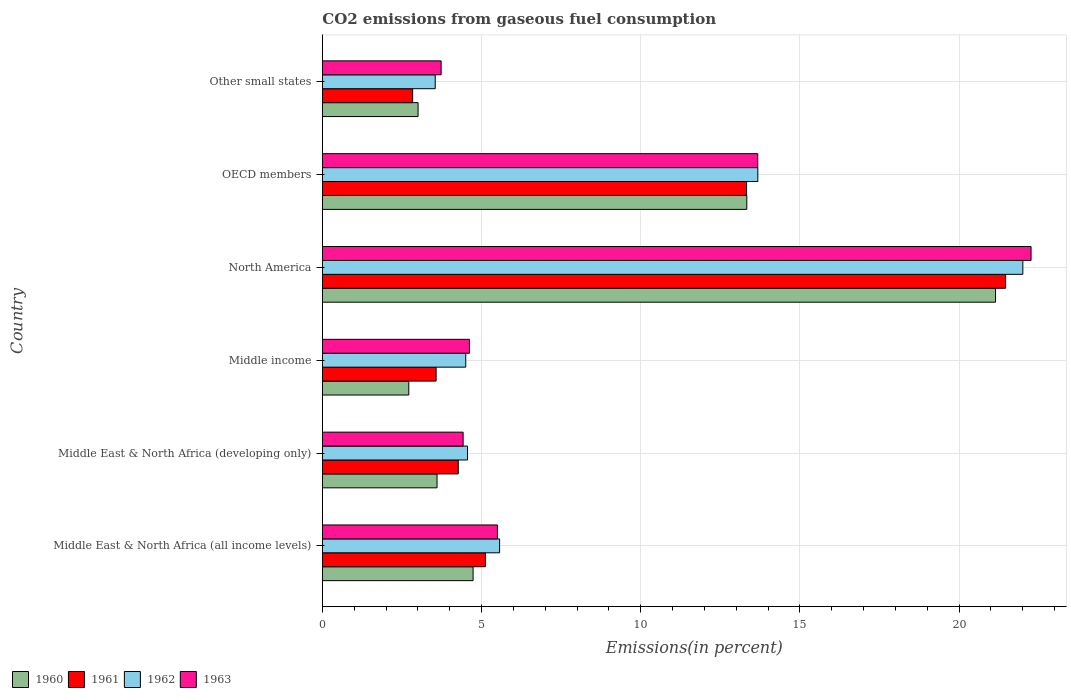How many groups of bars are there?
Make the answer very short. 6. How many bars are there on the 6th tick from the top?
Provide a succinct answer. 4. How many bars are there on the 3rd tick from the bottom?
Provide a short and direct response. 4. What is the label of the 1st group of bars from the top?
Offer a very short reply. Other small states. In how many cases, is the number of bars for a given country not equal to the number of legend labels?
Make the answer very short. 0. What is the total CO2 emitted in 1961 in OECD members?
Make the answer very short. 13.33. Across all countries, what is the maximum total CO2 emitted in 1961?
Your answer should be very brief. 21.46. Across all countries, what is the minimum total CO2 emitted in 1962?
Offer a very short reply. 3.55. In which country was the total CO2 emitted in 1961 minimum?
Offer a very short reply. Other small states. What is the total total CO2 emitted in 1962 in the graph?
Provide a succinct answer. 53.86. What is the difference between the total CO2 emitted in 1960 in Middle income and that in Other small states?
Offer a terse response. -0.29. What is the difference between the total CO2 emitted in 1961 in Middle income and the total CO2 emitted in 1963 in North America?
Your response must be concise. -18.69. What is the average total CO2 emitted in 1962 per country?
Give a very brief answer. 8.98. What is the difference between the total CO2 emitted in 1961 and total CO2 emitted in 1962 in OECD members?
Your answer should be very brief. -0.35. What is the ratio of the total CO2 emitted in 1961 in Middle East & North Africa (developing only) to that in North America?
Give a very brief answer. 0.2. Is the difference between the total CO2 emitted in 1961 in Middle income and OECD members greater than the difference between the total CO2 emitted in 1962 in Middle income and OECD members?
Your answer should be very brief. No. What is the difference between the highest and the second highest total CO2 emitted in 1961?
Offer a very short reply. 8.14. What is the difference between the highest and the lowest total CO2 emitted in 1960?
Make the answer very short. 18.43. Is the sum of the total CO2 emitted in 1963 in North America and Other small states greater than the maximum total CO2 emitted in 1960 across all countries?
Your answer should be very brief. Yes. What does the 3rd bar from the bottom in Middle East & North Africa (all income levels) represents?
Give a very brief answer. 1962. Is it the case that in every country, the sum of the total CO2 emitted in 1963 and total CO2 emitted in 1962 is greater than the total CO2 emitted in 1960?
Provide a succinct answer. Yes. Are all the bars in the graph horizontal?
Provide a succinct answer. Yes. What is the difference between two consecutive major ticks on the X-axis?
Make the answer very short. 5. Does the graph contain grids?
Offer a very short reply. Yes. Where does the legend appear in the graph?
Provide a succinct answer. Bottom left. How are the legend labels stacked?
Make the answer very short. Horizontal. What is the title of the graph?
Offer a terse response. CO2 emissions from gaseous fuel consumption. Does "2011" appear as one of the legend labels in the graph?
Your response must be concise. No. What is the label or title of the X-axis?
Your answer should be very brief. Emissions(in percent). What is the label or title of the Y-axis?
Provide a succinct answer. Country. What is the Emissions(in percent) of 1960 in Middle East & North Africa (all income levels)?
Your answer should be compact. 4.74. What is the Emissions(in percent) in 1961 in Middle East & North Africa (all income levels)?
Your response must be concise. 5.12. What is the Emissions(in percent) of 1962 in Middle East & North Africa (all income levels)?
Make the answer very short. 5.57. What is the Emissions(in percent) in 1963 in Middle East & North Africa (all income levels)?
Offer a very short reply. 5.5. What is the Emissions(in percent) in 1960 in Middle East & North Africa (developing only)?
Ensure brevity in your answer.  3.6. What is the Emissions(in percent) in 1961 in Middle East & North Africa (developing only)?
Provide a short and direct response. 4.27. What is the Emissions(in percent) of 1962 in Middle East & North Africa (developing only)?
Your answer should be compact. 4.56. What is the Emissions(in percent) of 1963 in Middle East & North Africa (developing only)?
Keep it short and to the point. 4.42. What is the Emissions(in percent) of 1960 in Middle income?
Your response must be concise. 2.72. What is the Emissions(in percent) of 1961 in Middle income?
Give a very brief answer. 3.57. What is the Emissions(in percent) in 1962 in Middle income?
Your answer should be very brief. 4.5. What is the Emissions(in percent) of 1963 in Middle income?
Make the answer very short. 4.62. What is the Emissions(in percent) of 1960 in North America?
Ensure brevity in your answer.  21.15. What is the Emissions(in percent) of 1961 in North America?
Ensure brevity in your answer.  21.46. What is the Emissions(in percent) of 1962 in North America?
Your response must be concise. 22. What is the Emissions(in percent) in 1963 in North America?
Provide a short and direct response. 22.26. What is the Emissions(in percent) in 1960 in OECD members?
Your response must be concise. 13.33. What is the Emissions(in percent) of 1961 in OECD members?
Provide a short and direct response. 13.33. What is the Emissions(in percent) in 1962 in OECD members?
Your response must be concise. 13.68. What is the Emissions(in percent) of 1963 in OECD members?
Your response must be concise. 13.68. What is the Emissions(in percent) of 1960 in Other small states?
Provide a short and direct response. 3.01. What is the Emissions(in percent) in 1961 in Other small states?
Your answer should be compact. 2.84. What is the Emissions(in percent) in 1962 in Other small states?
Offer a terse response. 3.55. What is the Emissions(in percent) in 1963 in Other small states?
Your response must be concise. 3.73. Across all countries, what is the maximum Emissions(in percent) in 1960?
Provide a succinct answer. 21.15. Across all countries, what is the maximum Emissions(in percent) in 1961?
Offer a very short reply. 21.46. Across all countries, what is the maximum Emissions(in percent) in 1962?
Your response must be concise. 22. Across all countries, what is the maximum Emissions(in percent) in 1963?
Offer a very short reply. 22.26. Across all countries, what is the minimum Emissions(in percent) in 1960?
Make the answer very short. 2.72. Across all countries, what is the minimum Emissions(in percent) in 1961?
Your answer should be compact. 2.84. Across all countries, what is the minimum Emissions(in percent) of 1962?
Your response must be concise. 3.55. Across all countries, what is the minimum Emissions(in percent) of 1963?
Give a very brief answer. 3.73. What is the total Emissions(in percent) of 1960 in the graph?
Your answer should be very brief. 48.54. What is the total Emissions(in percent) of 1961 in the graph?
Give a very brief answer. 50.59. What is the total Emissions(in percent) in 1962 in the graph?
Provide a succinct answer. 53.86. What is the total Emissions(in percent) of 1963 in the graph?
Your answer should be very brief. 54.21. What is the difference between the Emissions(in percent) of 1960 in Middle East & North Africa (all income levels) and that in Middle East & North Africa (developing only)?
Your answer should be very brief. 1.13. What is the difference between the Emissions(in percent) in 1961 in Middle East & North Africa (all income levels) and that in Middle East & North Africa (developing only)?
Make the answer very short. 0.85. What is the difference between the Emissions(in percent) in 1962 in Middle East & North Africa (all income levels) and that in Middle East & North Africa (developing only)?
Offer a very short reply. 1.01. What is the difference between the Emissions(in percent) in 1963 in Middle East & North Africa (all income levels) and that in Middle East & North Africa (developing only)?
Offer a terse response. 1.08. What is the difference between the Emissions(in percent) in 1960 in Middle East & North Africa (all income levels) and that in Middle income?
Ensure brevity in your answer.  2.02. What is the difference between the Emissions(in percent) in 1961 in Middle East & North Africa (all income levels) and that in Middle income?
Offer a very short reply. 1.55. What is the difference between the Emissions(in percent) in 1962 in Middle East & North Africa (all income levels) and that in Middle income?
Make the answer very short. 1.06. What is the difference between the Emissions(in percent) in 1963 in Middle East & North Africa (all income levels) and that in Middle income?
Your answer should be compact. 0.88. What is the difference between the Emissions(in percent) of 1960 in Middle East & North Africa (all income levels) and that in North America?
Offer a very short reply. -16.41. What is the difference between the Emissions(in percent) of 1961 in Middle East & North Africa (all income levels) and that in North America?
Your response must be concise. -16.34. What is the difference between the Emissions(in percent) in 1962 in Middle East & North Africa (all income levels) and that in North America?
Make the answer very short. -16.44. What is the difference between the Emissions(in percent) in 1963 in Middle East & North Africa (all income levels) and that in North America?
Make the answer very short. -16.76. What is the difference between the Emissions(in percent) of 1960 in Middle East & North Africa (all income levels) and that in OECD members?
Give a very brief answer. -8.6. What is the difference between the Emissions(in percent) in 1961 in Middle East & North Africa (all income levels) and that in OECD members?
Give a very brief answer. -8.2. What is the difference between the Emissions(in percent) in 1962 in Middle East & North Africa (all income levels) and that in OECD members?
Provide a short and direct response. -8.11. What is the difference between the Emissions(in percent) of 1963 in Middle East & North Africa (all income levels) and that in OECD members?
Provide a short and direct response. -8.18. What is the difference between the Emissions(in percent) in 1960 in Middle East & North Africa (all income levels) and that in Other small states?
Keep it short and to the point. 1.73. What is the difference between the Emissions(in percent) in 1961 in Middle East & North Africa (all income levels) and that in Other small states?
Your answer should be compact. 2.29. What is the difference between the Emissions(in percent) in 1962 in Middle East & North Africa (all income levels) and that in Other small states?
Offer a very short reply. 2.02. What is the difference between the Emissions(in percent) of 1963 in Middle East & North Africa (all income levels) and that in Other small states?
Provide a succinct answer. 1.77. What is the difference between the Emissions(in percent) in 1960 in Middle East & North Africa (developing only) and that in Middle income?
Offer a very short reply. 0.89. What is the difference between the Emissions(in percent) in 1961 in Middle East & North Africa (developing only) and that in Middle income?
Your answer should be very brief. 0.7. What is the difference between the Emissions(in percent) in 1962 in Middle East & North Africa (developing only) and that in Middle income?
Provide a succinct answer. 0.06. What is the difference between the Emissions(in percent) of 1963 in Middle East & North Africa (developing only) and that in Middle income?
Provide a succinct answer. -0.2. What is the difference between the Emissions(in percent) in 1960 in Middle East & North Africa (developing only) and that in North America?
Your answer should be compact. -17.54. What is the difference between the Emissions(in percent) of 1961 in Middle East & North Africa (developing only) and that in North America?
Give a very brief answer. -17.19. What is the difference between the Emissions(in percent) in 1962 in Middle East & North Africa (developing only) and that in North America?
Your answer should be compact. -17.44. What is the difference between the Emissions(in percent) in 1963 in Middle East & North Africa (developing only) and that in North America?
Make the answer very short. -17.84. What is the difference between the Emissions(in percent) in 1960 in Middle East & North Africa (developing only) and that in OECD members?
Keep it short and to the point. -9.73. What is the difference between the Emissions(in percent) in 1961 in Middle East & North Africa (developing only) and that in OECD members?
Ensure brevity in your answer.  -9.06. What is the difference between the Emissions(in percent) of 1962 in Middle East & North Africa (developing only) and that in OECD members?
Provide a succinct answer. -9.12. What is the difference between the Emissions(in percent) in 1963 in Middle East & North Africa (developing only) and that in OECD members?
Your answer should be compact. -9.25. What is the difference between the Emissions(in percent) in 1960 in Middle East & North Africa (developing only) and that in Other small states?
Give a very brief answer. 0.6. What is the difference between the Emissions(in percent) of 1961 in Middle East & North Africa (developing only) and that in Other small states?
Your answer should be compact. 1.43. What is the difference between the Emissions(in percent) of 1962 in Middle East & North Africa (developing only) and that in Other small states?
Provide a succinct answer. 1.01. What is the difference between the Emissions(in percent) in 1963 in Middle East & North Africa (developing only) and that in Other small states?
Make the answer very short. 0.69. What is the difference between the Emissions(in percent) in 1960 in Middle income and that in North America?
Give a very brief answer. -18.43. What is the difference between the Emissions(in percent) of 1961 in Middle income and that in North America?
Offer a very short reply. -17.89. What is the difference between the Emissions(in percent) of 1962 in Middle income and that in North America?
Give a very brief answer. -17.5. What is the difference between the Emissions(in percent) in 1963 in Middle income and that in North America?
Keep it short and to the point. -17.64. What is the difference between the Emissions(in percent) of 1960 in Middle income and that in OECD members?
Provide a succinct answer. -10.62. What is the difference between the Emissions(in percent) of 1961 in Middle income and that in OECD members?
Offer a terse response. -9.75. What is the difference between the Emissions(in percent) of 1962 in Middle income and that in OECD members?
Your answer should be very brief. -9.17. What is the difference between the Emissions(in percent) of 1963 in Middle income and that in OECD members?
Offer a very short reply. -9.06. What is the difference between the Emissions(in percent) of 1960 in Middle income and that in Other small states?
Make the answer very short. -0.29. What is the difference between the Emissions(in percent) of 1961 in Middle income and that in Other small states?
Make the answer very short. 0.74. What is the difference between the Emissions(in percent) in 1962 in Middle income and that in Other small states?
Keep it short and to the point. 0.96. What is the difference between the Emissions(in percent) in 1963 in Middle income and that in Other small states?
Your answer should be very brief. 0.89. What is the difference between the Emissions(in percent) of 1960 in North America and that in OECD members?
Your answer should be very brief. 7.81. What is the difference between the Emissions(in percent) in 1961 in North America and that in OECD members?
Provide a succinct answer. 8.14. What is the difference between the Emissions(in percent) in 1962 in North America and that in OECD members?
Make the answer very short. 8.32. What is the difference between the Emissions(in percent) in 1963 in North America and that in OECD members?
Keep it short and to the point. 8.58. What is the difference between the Emissions(in percent) of 1960 in North America and that in Other small states?
Provide a succinct answer. 18.14. What is the difference between the Emissions(in percent) in 1961 in North America and that in Other small states?
Give a very brief answer. 18.62. What is the difference between the Emissions(in percent) in 1962 in North America and that in Other small states?
Make the answer very short. 18.46. What is the difference between the Emissions(in percent) of 1963 in North America and that in Other small states?
Keep it short and to the point. 18.53. What is the difference between the Emissions(in percent) in 1960 in OECD members and that in Other small states?
Offer a terse response. 10.33. What is the difference between the Emissions(in percent) in 1961 in OECD members and that in Other small states?
Ensure brevity in your answer.  10.49. What is the difference between the Emissions(in percent) of 1962 in OECD members and that in Other small states?
Ensure brevity in your answer.  10.13. What is the difference between the Emissions(in percent) of 1963 in OECD members and that in Other small states?
Provide a succinct answer. 9.95. What is the difference between the Emissions(in percent) in 1960 in Middle East & North Africa (all income levels) and the Emissions(in percent) in 1961 in Middle East & North Africa (developing only)?
Your response must be concise. 0.47. What is the difference between the Emissions(in percent) in 1960 in Middle East & North Africa (all income levels) and the Emissions(in percent) in 1962 in Middle East & North Africa (developing only)?
Provide a succinct answer. 0.18. What is the difference between the Emissions(in percent) of 1960 in Middle East & North Africa (all income levels) and the Emissions(in percent) of 1963 in Middle East & North Africa (developing only)?
Your answer should be compact. 0.31. What is the difference between the Emissions(in percent) of 1961 in Middle East & North Africa (all income levels) and the Emissions(in percent) of 1962 in Middle East & North Africa (developing only)?
Provide a succinct answer. 0.56. What is the difference between the Emissions(in percent) of 1961 in Middle East & North Africa (all income levels) and the Emissions(in percent) of 1963 in Middle East & North Africa (developing only)?
Your answer should be very brief. 0.7. What is the difference between the Emissions(in percent) of 1962 in Middle East & North Africa (all income levels) and the Emissions(in percent) of 1963 in Middle East & North Africa (developing only)?
Your answer should be compact. 1.15. What is the difference between the Emissions(in percent) in 1960 in Middle East & North Africa (all income levels) and the Emissions(in percent) in 1961 in Middle income?
Make the answer very short. 1.16. What is the difference between the Emissions(in percent) in 1960 in Middle East & North Africa (all income levels) and the Emissions(in percent) in 1962 in Middle income?
Offer a terse response. 0.23. What is the difference between the Emissions(in percent) in 1960 in Middle East & North Africa (all income levels) and the Emissions(in percent) in 1963 in Middle income?
Offer a terse response. 0.12. What is the difference between the Emissions(in percent) in 1961 in Middle East & North Africa (all income levels) and the Emissions(in percent) in 1962 in Middle income?
Offer a very short reply. 0.62. What is the difference between the Emissions(in percent) of 1961 in Middle East & North Africa (all income levels) and the Emissions(in percent) of 1963 in Middle income?
Ensure brevity in your answer.  0.5. What is the difference between the Emissions(in percent) of 1962 in Middle East & North Africa (all income levels) and the Emissions(in percent) of 1963 in Middle income?
Your answer should be very brief. 0.95. What is the difference between the Emissions(in percent) of 1960 in Middle East & North Africa (all income levels) and the Emissions(in percent) of 1961 in North America?
Provide a succinct answer. -16.73. What is the difference between the Emissions(in percent) of 1960 in Middle East & North Africa (all income levels) and the Emissions(in percent) of 1962 in North America?
Your answer should be compact. -17.27. What is the difference between the Emissions(in percent) of 1960 in Middle East & North Africa (all income levels) and the Emissions(in percent) of 1963 in North America?
Ensure brevity in your answer.  -17.53. What is the difference between the Emissions(in percent) of 1961 in Middle East & North Africa (all income levels) and the Emissions(in percent) of 1962 in North America?
Offer a terse response. -16.88. What is the difference between the Emissions(in percent) in 1961 in Middle East & North Africa (all income levels) and the Emissions(in percent) in 1963 in North America?
Make the answer very short. -17.14. What is the difference between the Emissions(in percent) in 1962 in Middle East & North Africa (all income levels) and the Emissions(in percent) in 1963 in North America?
Offer a very short reply. -16.69. What is the difference between the Emissions(in percent) of 1960 in Middle East & North Africa (all income levels) and the Emissions(in percent) of 1961 in OECD members?
Provide a succinct answer. -8.59. What is the difference between the Emissions(in percent) of 1960 in Middle East & North Africa (all income levels) and the Emissions(in percent) of 1962 in OECD members?
Give a very brief answer. -8.94. What is the difference between the Emissions(in percent) of 1960 in Middle East & North Africa (all income levels) and the Emissions(in percent) of 1963 in OECD members?
Offer a terse response. -8.94. What is the difference between the Emissions(in percent) in 1961 in Middle East & North Africa (all income levels) and the Emissions(in percent) in 1962 in OECD members?
Ensure brevity in your answer.  -8.56. What is the difference between the Emissions(in percent) of 1961 in Middle East & North Africa (all income levels) and the Emissions(in percent) of 1963 in OECD members?
Keep it short and to the point. -8.55. What is the difference between the Emissions(in percent) of 1962 in Middle East & North Africa (all income levels) and the Emissions(in percent) of 1963 in OECD members?
Keep it short and to the point. -8.11. What is the difference between the Emissions(in percent) in 1960 in Middle East & North Africa (all income levels) and the Emissions(in percent) in 1961 in Other small states?
Provide a succinct answer. 1.9. What is the difference between the Emissions(in percent) of 1960 in Middle East & North Africa (all income levels) and the Emissions(in percent) of 1962 in Other small states?
Give a very brief answer. 1.19. What is the difference between the Emissions(in percent) of 1961 in Middle East & North Africa (all income levels) and the Emissions(in percent) of 1962 in Other small states?
Ensure brevity in your answer.  1.58. What is the difference between the Emissions(in percent) in 1961 in Middle East & North Africa (all income levels) and the Emissions(in percent) in 1963 in Other small states?
Give a very brief answer. 1.39. What is the difference between the Emissions(in percent) of 1962 in Middle East & North Africa (all income levels) and the Emissions(in percent) of 1963 in Other small states?
Make the answer very short. 1.84. What is the difference between the Emissions(in percent) in 1960 in Middle East & North Africa (developing only) and the Emissions(in percent) in 1961 in Middle income?
Make the answer very short. 0.03. What is the difference between the Emissions(in percent) of 1960 in Middle East & North Africa (developing only) and the Emissions(in percent) of 1962 in Middle income?
Ensure brevity in your answer.  -0.9. What is the difference between the Emissions(in percent) in 1960 in Middle East & North Africa (developing only) and the Emissions(in percent) in 1963 in Middle income?
Keep it short and to the point. -1.02. What is the difference between the Emissions(in percent) in 1961 in Middle East & North Africa (developing only) and the Emissions(in percent) in 1962 in Middle income?
Offer a terse response. -0.24. What is the difference between the Emissions(in percent) of 1961 in Middle East & North Africa (developing only) and the Emissions(in percent) of 1963 in Middle income?
Your response must be concise. -0.35. What is the difference between the Emissions(in percent) of 1962 in Middle East & North Africa (developing only) and the Emissions(in percent) of 1963 in Middle income?
Offer a terse response. -0.06. What is the difference between the Emissions(in percent) of 1960 in Middle East & North Africa (developing only) and the Emissions(in percent) of 1961 in North America?
Provide a short and direct response. -17.86. What is the difference between the Emissions(in percent) in 1960 in Middle East & North Africa (developing only) and the Emissions(in percent) in 1962 in North America?
Give a very brief answer. -18.4. What is the difference between the Emissions(in percent) in 1960 in Middle East & North Africa (developing only) and the Emissions(in percent) in 1963 in North America?
Keep it short and to the point. -18.66. What is the difference between the Emissions(in percent) in 1961 in Middle East & North Africa (developing only) and the Emissions(in percent) in 1962 in North America?
Make the answer very short. -17.73. What is the difference between the Emissions(in percent) of 1961 in Middle East & North Africa (developing only) and the Emissions(in percent) of 1963 in North America?
Keep it short and to the point. -17.99. What is the difference between the Emissions(in percent) in 1962 in Middle East & North Africa (developing only) and the Emissions(in percent) in 1963 in North America?
Provide a succinct answer. -17.7. What is the difference between the Emissions(in percent) in 1960 in Middle East & North Africa (developing only) and the Emissions(in percent) in 1961 in OECD members?
Offer a terse response. -9.72. What is the difference between the Emissions(in percent) of 1960 in Middle East & North Africa (developing only) and the Emissions(in percent) of 1962 in OECD members?
Keep it short and to the point. -10.08. What is the difference between the Emissions(in percent) in 1960 in Middle East & North Africa (developing only) and the Emissions(in percent) in 1963 in OECD members?
Provide a short and direct response. -10.07. What is the difference between the Emissions(in percent) of 1961 in Middle East & North Africa (developing only) and the Emissions(in percent) of 1962 in OECD members?
Offer a very short reply. -9.41. What is the difference between the Emissions(in percent) in 1961 in Middle East & North Africa (developing only) and the Emissions(in percent) in 1963 in OECD members?
Offer a terse response. -9.41. What is the difference between the Emissions(in percent) in 1962 in Middle East & North Africa (developing only) and the Emissions(in percent) in 1963 in OECD members?
Keep it short and to the point. -9.12. What is the difference between the Emissions(in percent) in 1960 in Middle East & North Africa (developing only) and the Emissions(in percent) in 1961 in Other small states?
Your response must be concise. 0.77. What is the difference between the Emissions(in percent) in 1960 in Middle East & North Africa (developing only) and the Emissions(in percent) in 1962 in Other small states?
Your answer should be very brief. 0.06. What is the difference between the Emissions(in percent) in 1960 in Middle East & North Africa (developing only) and the Emissions(in percent) in 1963 in Other small states?
Offer a very short reply. -0.13. What is the difference between the Emissions(in percent) of 1961 in Middle East & North Africa (developing only) and the Emissions(in percent) of 1962 in Other small states?
Make the answer very short. 0.72. What is the difference between the Emissions(in percent) of 1961 in Middle East & North Africa (developing only) and the Emissions(in percent) of 1963 in Other small states?
Keep it short and to the point. 0.54. What is the difference between the Emissions(in percent) of 1962 in Middle East & North Africa (developing only) and the Emissions(in percent) of 1963 in Other small states?
Keep it short and to the point. 0.83. What is the difference between the Emissions(in percent) in 1960 in Middle income and the Emissions(in percent) in 1961 in North America?
Make the answer very short. -18.75. What is the difference between the Emissions(in percent) of 1960 in Middle income and the Emissions(in percent) of 1962 in North America?
Offer a terse response. -19.29. What is the difference between the Emissions(in percent) in 1960 in Middle income and the Emissions(in percent) in 1963 in North America?
Keep it short and to the point. -19.55. What is the difference between the Emissions(in percent) in 1961 in Middle income and the Emissions(in percent) in 1962 in North America?
Your answer should be very brief. -18.43. What is the difference between the Emissions(in percent) of 1961 in Middle income and the Emissions(in percent) of 1963 in North America?
Your answer should be compact. -18.69. What is the difference between the Emissions(in percent) of 1962 in Middle income and the Emissions(in percent) of 1963 in North America?
Your answer should be very brief. -17.76. What is the difference between the Emissions(in percent) of 1960 in Middle income and the Emissions(in percent) of 1961 in OECD members?
Provide a short and direct response. -10.61. What is the difference between the Emissions(in percent) in 1960 in Middle income and the Emissions(in percent) in 1962 in OECD members?
Make the answer very short. -10.96. What is the difference between the Emissions(in percent) in 1960 in Middle income and the Emissions(in percent) in 1963 in OECD members?
Your answer should be very brief. -10.96. What is the difference between the Emissions(in percent) of 1961 in Middle income and the Emissions(in percent) of 1962 in OECD members?
Ensure brevity in your answer.  -10.11. What is the difference between the Emissions(in percent) of 1961 in Middle income and the Emissions(in percent) of 1963 in OECD members?
Give a very brief answer. -10.1. What is the difference between the Emissions(in percent) in 1962 in Middle income and the Emissions(in percent) in 1963 in OECD members?
Your response must be concise. -9.17. What is the difference between the Emissions(in percent) in 1960 in Middle income and the Emissions(in percent) in 1961 in Other small states?
Your answer should be compact. -0.12. What is the difference between the Emissions(in percent) of 1960 in Middle income and the Emissions(in percent) of 1962 in Other small states?
Provide a succinct answer. -0.83. What is the difference between the Emissions(in percent) in 1960 in Middle income and the Emissions(in percent) in 1963 in Other small states?
Keep it short and to the point. -1.02. What is the difference between the Emissions(in percent) of 1961 in Middle income and the Emissions(in percent) of 1962 in Other small states?
Your answer should be compact. 0.03. What is the difference between the Emissions(in percent) in 1961 in Middle income and the Emissions(in percent) in 1963 in Other small states?
Offer a very short reply. -0.16. What is the difference between the Emissions(in percent) of 1962 in Middle income and the Emissions(in percent) of 1963 in Other small states?
Provide a short and direct response. 0.77. What is the difference between the Emissions(in percent) of 1960 in North America and the Emissions(in percent) of 1961 in OECD members?
Provide a succinct answer. 7.82. What is the difference between the Emissions(in percent) of 1960 in North America and the Emissions(in percent) of 1962 in OECD members?
Offer a very short reply. 7.47. What is the difference between the Emissions(in percent) of 1960 in North America and the Emissions(in percent) of 1963 in OECD members?
Offer a terse response. 7.47. What is the difference between the Emissions(in percent) of 1961 in North America and the Emissions(in percent) of 1962 in OECD members?
Make the answer very short. 7.78. What is the difference between the Emissions(in percent) of 1961 in North America and the Emissions(in percent) of 1963 in OECD members?
Your answer should be very brief. 7.78. What is the difference between the Emissions(in percent) in 1962 in North America and the Emissions(in percent) in 1963 in OECD members?
Give a very brief answer. 8.33. What is the difference between the Emissions(in percent) of 1960 in North America and the Emissions(in percent) of 1961 in Other small states?
Make the answer very short. 18.31. What is the difference between the Emissions(in percent) of 1960 in North America and the Emissions(in percent) of 1962 in Other small states?
Keep it short and to the point. 17.6. What is the difference between the Emissions(in percent) in 1960 in North America and the Emissions(in percent) in 1963 in Other small states?
Make the answer very short. 17.41. What is the difference between the Emissions(in percent) of 1961 in North America and the Emissions(in percent) of 1962 in Other small states?
Provide a short and direct response. 17.92. What is the difference between the Emissions(in percent) of 1961 in North America and the Emissions(in percent) of 1963 in Other small states?
Make the answer very short. 17.73. What is the difference between the Emissions(in percent) in 1962 in North America and the Emissions(in percent) in 1963 in Other small states?
Provide a short and direct response. 18.27. What is the difference between the Emissions(in percent) of 1960 in OECD members and the Emissions(in percent) of 1961 in Other small states?
Keep it short and to the point. 10.5. What is the difference between the Emissions(in percent) of 1960 in OECD members and the Emissions(in percent) of 1962 in Other small states?
Provide a short and direct response. 9.79. What is the difference between the Emissions(in percent) in 1960 in OECD members and the Emissions(in percent) in 1963 in Other small states?
Ensure brevity in your answer.  9.6. What is the difference between the Emissions(in percent) in 1961 in OECD members and the Emissions(in percent) in 1962 in Other small states?
Your answer should be very brief. 9.78. What is the difference between the Emissions(in percent) in 1961 in OECD members and the Emissions(in percent) in 1963 in Other small states?
Ensure brevity in your answer.  9.59. What is the difference between the Emissions(in percent) in 1962 in OECD members and the Emissions(in percent) in 1963 in Other small states?
Give a very brief answer. 9.95. What is the average Emissions(in percent) of 1960 per country?
Keep it short and to the point. 8.09. What is the average Emissions(in percent) of 1961 per country?
Provide a succinct answer. 8.43. What is the average Emissions(in percent) of 1962 per country?
Give a very brief answer. 8.98. What is the average Emissions(in percent) of 1963 per country?
Provide a short and direct response. 9.04. What is the difference between the Emissions(in percent) of 1960 and Emissions(in percent) of 1961 in Middle East & North Africa (all income levels)?
Make the answer very short. -0.39. What is the difference between the Emissions(in percent) of 1960 and Emissions(in percent) of 1962 in Middle East & North Africa (all income levels)?
Offer a terse response. -0.83. What is the difference between the Emissions(in percent) of 1960 and Emissions(in percent) of 1963 in Middle East & North Africa (all income levels)?
Your response must be concise. -0.76. What is the difference between the Emissions(in percent) of 1961 and Emissions(in percent) of 1962 in Middle East & North Africa (all income levels)?
Make the answer very short. -0.45. What is the difference between the Emissions(in percent) of 1961 and Emissions(in percent) of 1963 in Middle East & North Africa (all income levels)?
Ensure brevity in your answer.  -0.38. What is the difference between the Emissions(in percent) in 1962 and Emissions(in percent) in 1963 in Middle East & North Africa (all income levels)?
Provide a short and direct response. 0.07. What is the difference between the Emissions(in percent) of 1960 and Emissions(in percent) of 1961 in Middle East & North Africa (developing only)?
Keep it short and to the point. -0.67. What is the difference between the Emissions(in percent) of 1960 and Emissions(in percent) of 1962 in Middle East & North Africa (developing only)?
Make the answer very short. -0.96. What is the difference between the Emissions(in percent) of 1960 and Emissions(in percent) of 1963 in Middle East & North Africa (developing only)?
Provide a succinct answer. -0.82. What is the difference between the Emissions(in percent) in 1961 and Emissions(in percent) in 1962 in Middle East & North Africa (developing only)?
Provide a succinct answer. -0.29. What is the difference between the Emissions(in percent) of 1961 and Emissions(in percent) of 1963 in Middle East & North Africa (developing only)?
Your answer should be very brief. -0.15. What is the difference between the Emissions(in percent) of 1962 and Emissions(in percent) of 1963 in Middle East & North Africa (developing only)?
Your response must be concise. 0.14. What is the difference between the Emissions(in percent) of 1960 and Emissions(in percent) of 1961 in Middle income?
Provide a succinct answer. -0.86. What is the difference between the Emissions(in percent) of 1960 and Emissions(in percent) of 1962 in Middle income?
Provide a short and direct response. -1.79. What is the difference between the Emissions(in percent) of 1960 and Emissions(in percent) of 1963 in Middle income?
Make the answer very short. -1.91. What is the difference between the Emissions(in percent) of 1961 and Emissions(in percent) of 1962 in Middle income?
Your response must be concise. -0.93. What is the difference between the Emissions(in percent) in 1961 and Emissions(in percent) in 1963 in Middle income?
Provide a short and direct response. -1.05. What is the difference between the Emissions(in percent) of 1962 and Emissions(in percent) of 1963 in Middle income?
Your answer should be compact. -0.12. What is the difference between the Emissions(in percent) of 1960 and Emissions(in percent) of 1961 in North America?
Ensure brevity in your answer.  -0.32. What is the difference between the Emissions(in percent) of 1960 and Emissions(in percent) of 1962 in North America?
Your response must be concise. -0.86. What is the difference between the Emissions(in percent) in 1960 and Emissions(in percent) in 1963 in North America?
Make the answer very short. -1.12. What is the difference between the Emissions(in percent) of 1961 and Emissions(in percent) of 1962 in North America?
Your response must be concise. -0.54. What is the difference between the Emissions(in percent) of 1961 and Emissions(in percent) of 1963 in North America?
Your response must be concise. -0.8. What is the difference between the Emissions(in percent) in 1962 and Emissions(in percent) in 1963 in North America?
Offer a very short reply. -0.26. What is the difference between the Emissions(in percent) of 1960 and Emissions(in percent) of 1961 in OECD members?
Keep it short and to the point. 0.01. What is the difference between the Emissions(in percent) in 1960 and Emissions(in percent) in 1962 in OECD members?
Your answer should be compact. -0.35. What is the difference between the Emissions(in percent) in 1960 and Emissions(in percent) in 1963 in OECD members?
Your response must be concise. -0.34. What is the difference between the Emissions(in percent) in 1961 and Emissions(in percent) in 1962 in OECD members?
Make the answer very short. -0.35. What is the difference between the Emissions(in percent) of 1961 and Emissions(in percent) of 1963 in OECD members?
Keep it short and to the point. -0.35. What is the difference between the Emissions(in percent) of 1962 and Emissions(in percent) of 1963 in OECD members?
Make the answer very short. 0. What is the difference between the Emissions(in percent) of 1960 and Emissions(in percent) of 1961 in Other small states?
Your answer should be compact. 0.17. What is the difference between the Emissions(in percent) in 1960 and Emissions(in percent) in 1962 in Other small states?
Ensure brevity in your answer.  -0.54. What is the difference between the Emissions(in percent) of 1960 and Emissions(in percent) of 1963 in Other small states?
Your answer should be compact. -0.72. What is the difference between the Emissions(in percent) of 1961 and Emissions(in percent) of 1962 in Other small states?
Make the answer very short. -0.71. What is the difference between the Emissions(in percent) in 1961 and Emissions(in percent) in 1963 in Other small states?
Make the answer very short. -0.89. What is the difference between the Emissions(in percent) of 1962 and Emissions(in percent) of 1963 in Other small states?
Give a very brief answer. -0.19. What is the ratio of the Emissions(in percent) of 1960 in Middle East & North Africa (all income levels) to that in Middle East & North Africa (developing only)?
Ensure brevity in your answer.  1.31. What is the ratio of the Emissions(in percent) of 1961 in Middle East & North Africa (all income levels) to that in Middle East & North Africa (developing only)?
Offer a terse response. 1.2. What is the ratio of the Emissions(in percent) of 1962 in Middle East & North Africa (all income levels) to that in Middle East & North Africa (developing only)?
Your response must be concise. 1.22. What is the ratio of the Emissions(in percent) of 1963 in Middle East & North Africa (all income levels) to that in Middle East & North Africa (developing only)?
Your response must be concise. 1.24. What is the ratio of the Emissions(in percent) of 1960 in Middle East & North Africa (all income levels) to that in Middle income?
Provide a short and direct response. 1.74. What is the ratio of the Emissions(in percent) of 1961 in Middle East & North Africa (all income levels) to that in Middle income?
Your response must be concise. 1.43. What is the ratio of the Emissions(in percent) in 1962 in Middle East & North Africa (all income levels) to that in Middle income?
Offer a very short reply. 1.24. What is the ratio of the Emissions(in percent) in 1963 in Middle East & North Africa (all income levels) to that in Middle income?
Ensure brevity in your answer.  1.19. What is the ratio of the Emissions(in percent) of 1960 in Middle East & North Africa (all income levels) to that in North America?
Provide a succinct answer. 0.22. What is the ratio of the Emissions(in percent) of 1961 in Middle East & North Africa (all income levels) to that in North America?
Your answer should be compact. 0.24. What is the ratio of the Emissions(in percent) in 1962 in Middle East & North Africa (all income levels) to that in North America?
Give a very brief answer. 0.25. What is the ratio of the Emissions(in percent) of 1963 in Middle East & North Africa (all income levels) to that in North America?
Offer a terse response. 0.25. What is the ratio of the Emissions(in percent) in 1960 in Middle East & North Africa (all income levels) to that in OECD members?
Ensure brevity in your answer.  0.36. What is the ratio of the Emissions(in percent) of 1961 in Middle East & North Africa (all income levels) to that in OECD members?
Give a very brief answer. 0.38. What is the ratio of the Emissions(in percent) in 1962 in Middle East & North Africa (all income levels) to that in OECD members?
Provide a short and direct response. 0.41. What is the ratio of the Emissions(in percent) of 1963 in Middle East & North Africa (all income levels) to that in OECD members?
Keep it short and to the point. 0.4. What is the ratio of the Emissions(in percent) of 1960 in Middle East & North Africa (all income levels) to that in Other small states?
Provide a short and direct response. 1.57. What is the ratio of the Emissions(in percent) in 1961 in Middle East & North Africa (all income levels) to that in Other small states?
Give a very brief answer. 1.81. What is the ratio of the Emissions(in percent) in 1962 in Middle East & North Africa (all income levels) to that in Other small states?
Provide a succinct answer. 1.57. What is the ratio of the Emissions(in percent) of 1963 in Middle East & North Africa (all income levels) to that in Other small states?
Offer a terse response. 1.47. What is the ratio of the Emissions(in percent) of 1960 in Middle East & North Africa (developing only) to that in Middle income?
Offer a very short reply. 1.33. What is the ratio of the Emissions(in percent) of 1961 in Middle East & North Africa (developing only) to that in Middle income?
Offer a very short reply. 1.19. What is the ratio of the Emissions(in percent) of 1962 in Middle East & North Africa (developing only) to that in Middle income?
Ensure brevity in your answer.  1.01. What is the ratio of the Emissions(in percent) of 1963 in Middle East & North Africa (developing only) to that in Middle income?
Your answer should be compact. 0.96. What is the ratio of the Emissions(in percent) of 1960 in Middle East & North Africa (developing only) to that in North America?
Ensure brevity in your answer.  0.17. What is the ratio of the Emissions(in percent) in 1961 in Middle East & North Africa (developing only) to that in North America?
Your answer should be compact. 0.2. What is the ratio of the Emissions(in percent) of 1962 in Middle East & North Africa (developing only) to that in North America?
Ensure brevity in your answer.  0.21. What is the ratio of the Emissions(in percent) in 1963 in Middle East & North Africa (developing only) to that in North America?
Offer a terse response. 0.2. What is the ratio of the Emissions(in percent) in 1960 in Middle East & North Africa (developing only) to that in OECD members?
Give a very brief answer. 0.27. What is the ratio of the Emissions(in percent) in 1961 in Middle East & North Africa (developing only) to that in OECD members?
Keep it short and to the point. 0.32. What is the ratio of the Emissions(in percent) in 1962 in Middle East & North Africa (developing only) to that in OECD members?
Keep it short and to the point. 0.33. What is the ratio of the Emissions(in percent) in 1963 in Middle East & North Africa (developing only) to that in OECD members?
Your answer should be compact. 0.32. What is the ratio of the Emissions(in percent) of 1960 in Middle East & North Africa (developing only) to that in Other small states?
Ensure brevity in your answer.  1.2. What is the ratio of the Emissions(in percent) in 1961 in Middle East & North Africa (developing only) to that in Other small states?
Provide a succinct answer. 1.51. What is the ratio of the Emissions(in percent) of 1962 in Middle East & North Africa (developing only) to that in Other small states?
Your response must be concise. 1.29. What is the ratio of the Emissions(in percent) in 1963 in Middle East & North Africa (developing only) to that in Other small states?
Ensure brevity in your answer.  1.19. What is the ratio of the Emissions(in percent) of 1960 in Middle income to that in North America?
Give a very brief answer. 0.13. What is the ratio of the Emissions(in percent) of 1961 in Middle income to that in North America?
Keep it short and to the point. 0.17. What is the ratio of the Emissions(in percent) of 1962 in Middle income to that in North America?
Offer a very short reply. 0.2. What is the ratio of the Emissions(in percent) of 1963 in Middle income to that in North America?
Provide a short and direct response. 0.21. What is the ratio of the Emissions(in percent) of 1960 in Middle income to that in OECD members?
Provide a short and direct response. 0.2. What is the ratio of the Emissions(in percent) in 1961 in Middle income to that in OECD members?
Provide a succinct answer. 0.27. What is the ratio of the Emissions(in percent) in 1962 in Middle income to that in OECD members?
Offer a very short reply. 0.33. What is the ratio of the Emissions(in percent) in 1963 in Middle income to that in OECD members?
Provide a short and direct response. 0.34. What is the ratio of the Emissions(in percent) of 1960 in Middle income to that in Other small states?
Keep it short and to the point. 0.9. What is the ratio of the Emissions(in percent) of 1961 in Middle income to that in Other small states?
Keep it short and to the point. 1.26. What is the ratio of the Emissions(in percent) of 1962 in Middle income to that in Other small states?
Provide a succinct answer. 1.27. What is the ratio of the Emissions(in percent) of 1963 in Middle income to that in Other small states?
Your answer should be very brief. 1.24. What is the ratio of the Emissions(in percent) of 1960 in North America to that in OECD members?
Make the answer very short. 1.59. What is the ratio of the Emissions(in percent) of 1961 in North America to that in OECD members?
Your answer should be compact. 1.61. What is the ratio of the Emissions(in percent) in 1962 in North America to that in OECD members?
Your answer should be very brief. 1.61. What is the ratio of the Emissions(in percent) of 1963 in North America to that in OECD members?
Ensure brevity in your answer.  1.63. What is the ratio of the Emissions(in percent) of 1960 in North America to that in Other small states?
Keep it short and to the point. 7.03. What is the ratio of the Emissions(in percent) in 1961 in North America to that in Other small states?
Offer a terse response. 7.57. What is the ratio of the Emissions(in percent) of 1962 in North America to that in Other small states?
Your answer should be very brief. 6.21. What is the ratio of the Emissions(in percent) of 1963 in North America to that in Other small states?
Offer a terse response. 5.97. What is the ratio of the Emissions(in percent) of 1960 in OECD members to that in Other small states?
Your answer should be compact. 4.43. What is the ratio of the Emissions(in percent) of 1961 in OECD members to that in Other small states?
Keep it short and to the point. 4.7. What is the ratio of the Emissions(in percent) in 1962 in OECD members to that in Other small states?
Offer a terse response. 3.86. What is the ratio of the Emissions(in percent) of 1963 in OECD members to that in Other small states?
Keep it short and to the point. 3.67. What is the difference between the highest and the second highest Emissions(in percent) in 1960?
Give a very brief answer. 7.81. What is the difference between the highest and the second highest Emissions(in percent) of 1961?
Your response must be concise. 8.14. What is the difference between the highest and the second highest Emissions(in percent) of 1962?
Your response must be concise. 8.32. What is the difference between the highest and the second highest Emissions(in percent) in 1963?
Make the answer very short. 8.58. What is the difference between the highest and the lowest Emissions(in percent) of 1960?
Your answer should be very brief. 18.43. What is the difference between the highest and the lowest Emissions(in percent) in 1961?
Keep it short and to the point. 18.62. What is the difference between the highest and the lowest Emissions(in percent) of 1962?
Provide a succinct answer. 18.46. What is the difference between the highest and the lowest Emissions(in percent) of 1963?
Provide a short and direct response. 18.53. 